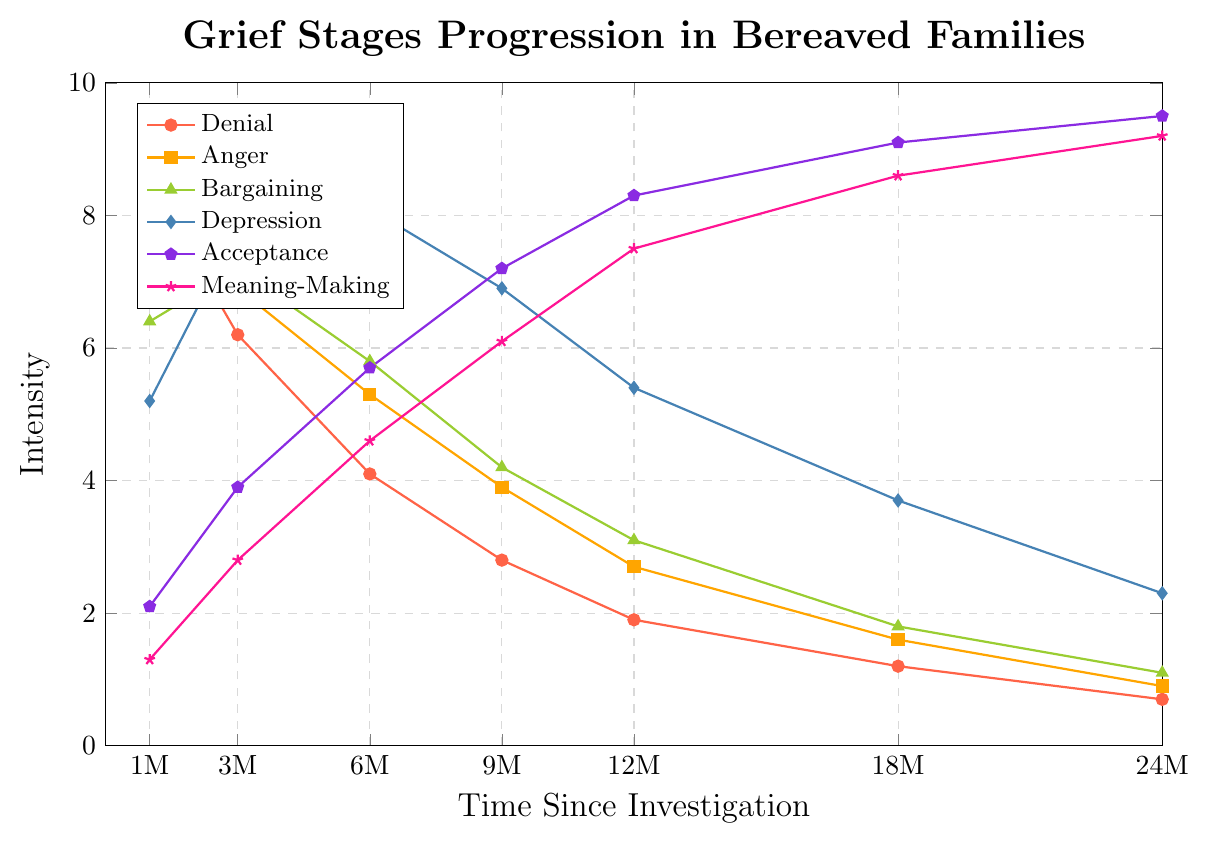What is the intensity of denial at 6 months? The y-axis represents intensity and the x-axis represents time since the investigation. At 6 months, the denial line reaches to approximately 4.1 on the y-axis.
Answer: 4.1 Which stage shows the highest intensity at 24 months? By examining the endpoints of each line on the plot at 24 months, the Acceptance stage has the highest intensity value, which is about 9.5.
Answer: Acceptance At which time point does anger's intensity fall below 4? Following the Anger line downwards, the intensity drops below 4 between 9 months and 12 months, at precisely 9 months where it reaches 3.9.
Answer: 9 months How do the intensity values of bargaining and meaning-making compare at the 18-month mark? At 18 months, Bargaining has an intensity of about 1.8 while Meaning-Making shows an intensity of approximately 8.6. Meaning-Making is significantly higher.
Answer: Meaning-Making is higher at 18 months What is the rate of decrease in denial intensity from 1 month to 3 months? Intensity at 1 month for denial is 8.5 and at 3 months it is 6.2. The rate of decrease is (8.5 - 6.2) / (3 - 1) = 2.3 / 2 = 1.15 per month.
Answer: 1.15 per month How does the intensity of depression at 9 months compare to that of acceptance at the same time? At 9 months, the intensity value for Depression is 6.9 whereas for Acceptance it's about 7.2. Acceptance is slightly higher than Depression.
Answer: Acceptance is higher At what time does the intensity for depression peak, and what is its value? The intensity for Depression peaks at 6 months, with a value of 8.1 on the y-axis.
Answer: 6 months, 8.1 What is the combined intensity of denial and anger at 12 months? At 12 months, the intensity of Denial is 1.9 and Anger is 2.7. Summing these gives 1.9 + 2.7 = 4.6.
Answer: 4.6 Between which time intervals does bargaining intensity increase then decrease, and what are these corresponding values? Observing the Bargaining line, the intensity increases from 1 month (6.4) to 3 months (7.2), and then starts to decrease at 6 months (5.8).
Answer: 1 month to 3 months (increases), 3 months to 6 months (decreases) At 24 months, which stages have intensified to an extent that they are above the midpoint intensity value of 5? At 24 months, Acceptance (9.5) and Meaning-Making (9.2) have intensities above 5.
Answer: Acceptance, Meaning-Making 